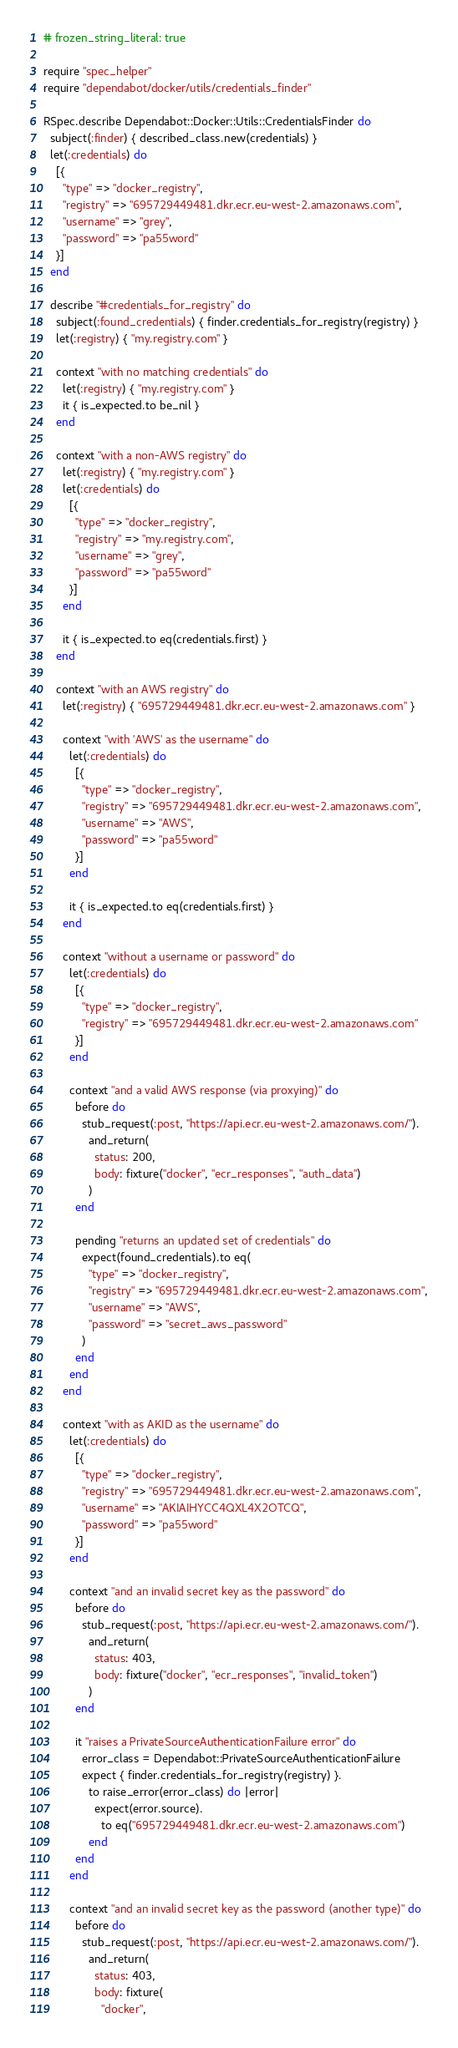<code> <loc_0><loc_0><loc_500><loc_500><_Ruby_># frozen_string_literal: true

require "spec_helper"
require "dependabot/docker/utils/credentials_finder"

RSpec.describe Dependabot::Docker::Utils::CredentialsFinder do
  subject(:finder) { described_class.new(credentials) }
  let(:credentials) do
    [{
      "type" => "docker_registry",
      "registry" => "695729449481.dkr.ecr.eu-west-2.amazonaws.com",
      "username" => "grey",
      "password" => "pa55word"
    }]
  end

  describe "#credentials_for_registry" do
    subject(:found_credentials) { finder.credentials_for_registry(registry) }
    let(:registry) { "my.registry.com" }

    context "with no matching credentials" do
      let(:registry) { "my.registry.com" }
      it { is_expected.to be_nil }
    end

    context "with a non-AWS registry" do
      let(:registry) { "my.registry.com" }
      let(:credentials) do
        [{
          "type" => "docker_registry",
          "registry" => "my.registry.com",
          "username" => "grey",
          "password" => "pa55word"
        }]
      end

      it { is_expected.to eq(credentials.first) }
    end

    context "with an AWS registry" do
      let(:registry) { "695729449481.dkr.ecr.eu-west-2.amazonaws.com" }

      context "with 'AWS' as the username" do
        let(:credentials) do
          [{
            "type" => "docker_registry",
            "registry" => "695729449481.dkr.ecr.eu-west-2.amazonaws.com",
            "username" => "AWS",
            "password" => "pa55word"
          }]
        end

        it { is_expected.to eq(credentials.first) }
      end

      context "without a username or password" do
        let(:credentials) do
          [{
            "type" => "docker_registry",
            "registry" => "695729449481.dkr.ecr.eu-west-2.amazonaws.com"
          }]
        end

        context "and a valid AWS response (via proxying)" do
          before do
            stub_request(:post, "https://api.ecr.eu-west-2.amazonaws.com/").
              and_return(
                status: 200,
                body: fixture("docker", "ecr_responses", "auth_data")
              )
          end

          pending "returns an updated set of credentials" do
            expect(found_credentials).to eq(
              "type" => "docker_registry",
              "registry" => "695729449481.dkr.ecr.eu-west-2.amazonaws.com",
              "username" => "AWS",
              "password" => "secret_aws_password"
            )
          end
        end
      end

      context "with as AKID as the username" do
        let(:credentials) do
          [{
            "type" => "docker_registry",
            "registry" => "695729449481.dkr.ecr.eu-west-2.amazonaws.com",
            "username" => "AKIAIHYCC4QXL4X2OTCQ",
            "password" => "pa55word"
          }]
        end

        context "and an invalid secret key as the password" do
          before do
            stub_request(:post, "https://api.ecr.eu-west-2.amazonaws.com/").
              and_return(
                status: 403,
                body: fixture("docker", "ecr_responses", "invalid_token")
              )
          end

          it "raises a PrivateSourceAuthenticationFailure error" do
            error_class = Dependabot::PrivateSourceAuthenticationFailure
            expect { finder.credentials_for_registry(registry) }.
              to raise_error(error_class) do |error|
                expect(error.source).
                  to eq("695729449481.dkr.ecr.eu-west-2.amazonaws.com")
              end
          end
        end

        context "and an invalid secret key as the password (another type)" do
          before do
            stub_request(:post, "https://api.ecr.eu-west-2.amazonaws.com/").
              and_return(
                status: 403,
                body: fixture(
                  "docker",</code> 